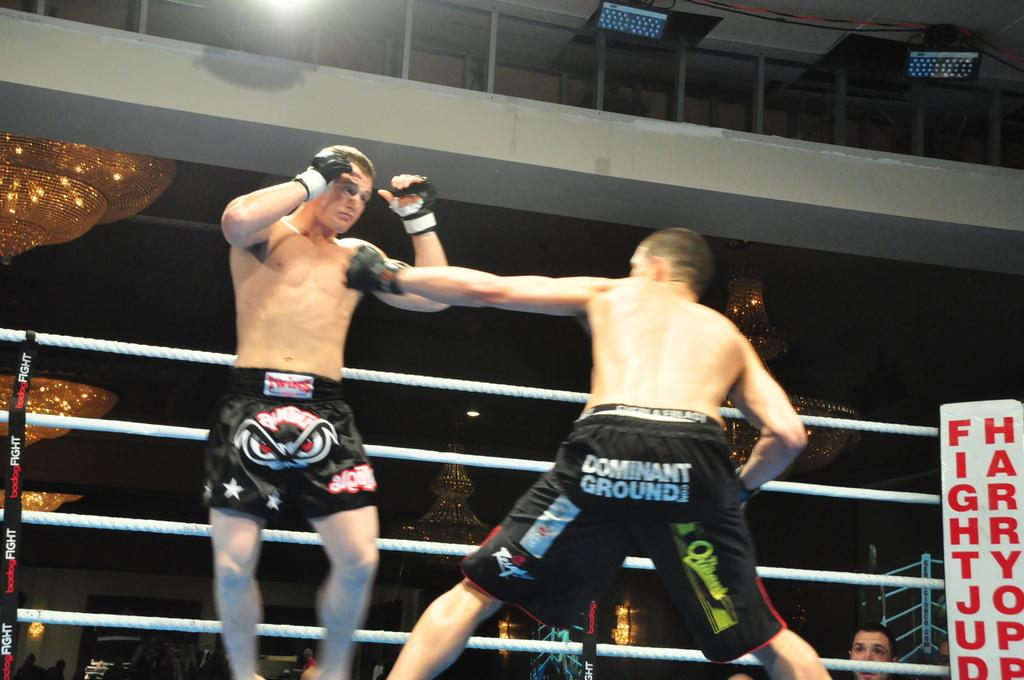<image>
Relay a brief, clear account of the picture shown. Two men boxing with one man wearing shorts that says "Dominant Ground". 